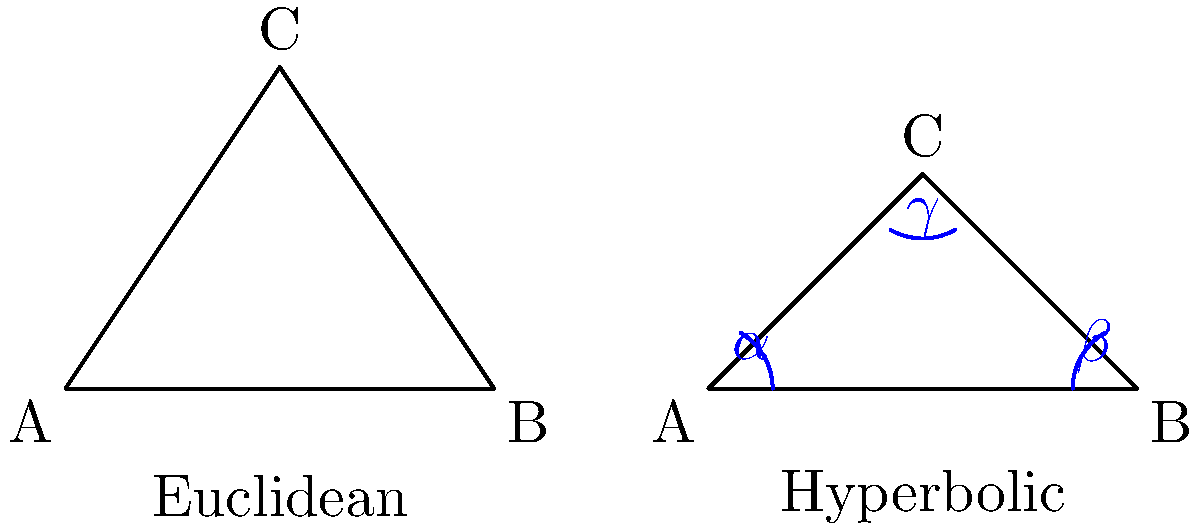As a business executive promoting continuous learning, you're exploring advanced mathematical concepts. Compare the sum of interior angles in a hyperbolic triangle to that of a Euclidean triangle. How does this difference reflect the nature of hyperbolic geometry, and what implications might this have for innovative problem-solving in business? To understand the difference between hyperbolic and Euclidean triangles:

1. Euclidean triangles:
   - The sum of interior angles is always 180°.
   - Expressed mathematically: $\alpha + \beta + \gamma = 180°$

2. Hyperbolic triangles:
   - The sum of interior angles is always less than 180°.
   - Expressed mathematically: $\alpha + \beta + \gamma < 180°$

3. Key differences:
   - In hyperbolic geometry, the defect (difference from 180°) is proportional to the area of the triangle.
   - As triangles get larger in hyperbolic space, their angle sum decreases.

4. Implications for innovative problem-solving:
   - Demonstrates that seemingly fundamental rules can change under different conditions.
   - Encourages thinking beyond traditional constraints.
   - Illustrates how alternative frameworks can lead to new solutions.

5. Business application:
   - Promotes adaptability in problem-solving approaches.
   - Encourages considering multiple perspectives when addressing challenges.
   - Demonstrates the value of exploring unconventional ideas in innovation.

The key takeaway is that the sum of angles in a hyperbolic triangle is always less than 180°, contrary to Euclidean geometry, which can inspire innovative thinking in business contexts.
Answer: Sum of angles in hyperbolic triangle < 180°; in Euclidean = 180°. Encourages innovative, non-traditional problem-solving in business. 